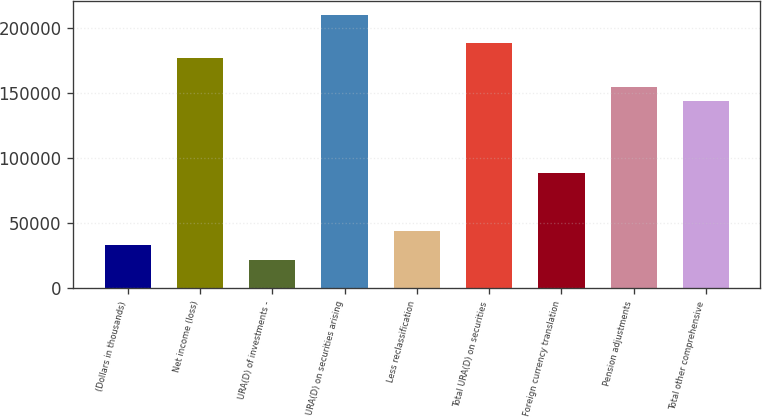Convert chart. <chart><loc_0><loc_0><loc_500><loc_500><bar_chart><fcel>(Dollars in thousands)<fcel>Net income (loss)<fcel>URA(D) of investments -<fcel>URA(D) on securities arising<fcel>Less reclassification<fcel>Total URA(D) on securities<fcel>Foreign currency translation<fcel>Pension adjustments<fcel>Total other comprehensive<nl><fcel>33271.8<fcel>177164<fcel>22203.2<fcel>210369<fcel>44340.4<fcel>188232<fcel>88614.8<fcel>155026<fcel>143958<nl></chart> 